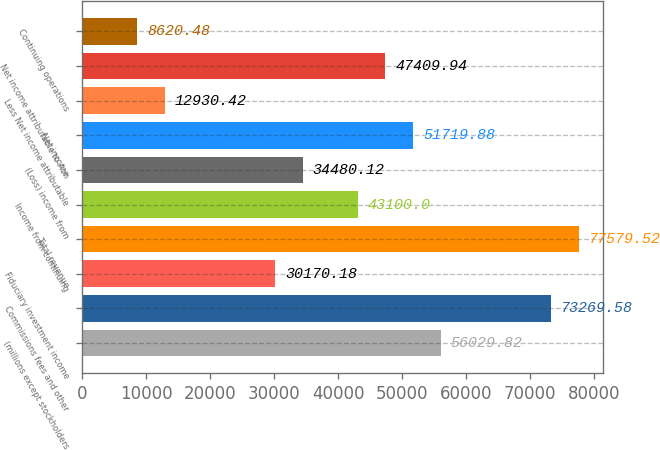Convert chart. <chart><loc_0><loc_0><loc_500><loc_500><bar_chart><fcel>(millions except stockholders<fcel>Commissions fees and other<fcel>Fiduciary investment income<fcel>Total revenue<fcel>Income from continuing<fcel>(Loss) income from<fcel>Net income<fcel>Less Net income attributable<fcel>Net income attributable to Aon<fcel>Continuing operations<nl><fcel>56029.8<fcel>73269.6<fcel>30170.2<fcel>77579.5<fcel>43100<fcel>34480.1<fcel>51719.9<fcel>12930.4<fcel>47409.9<fcel>8620.48<nl></chart> 